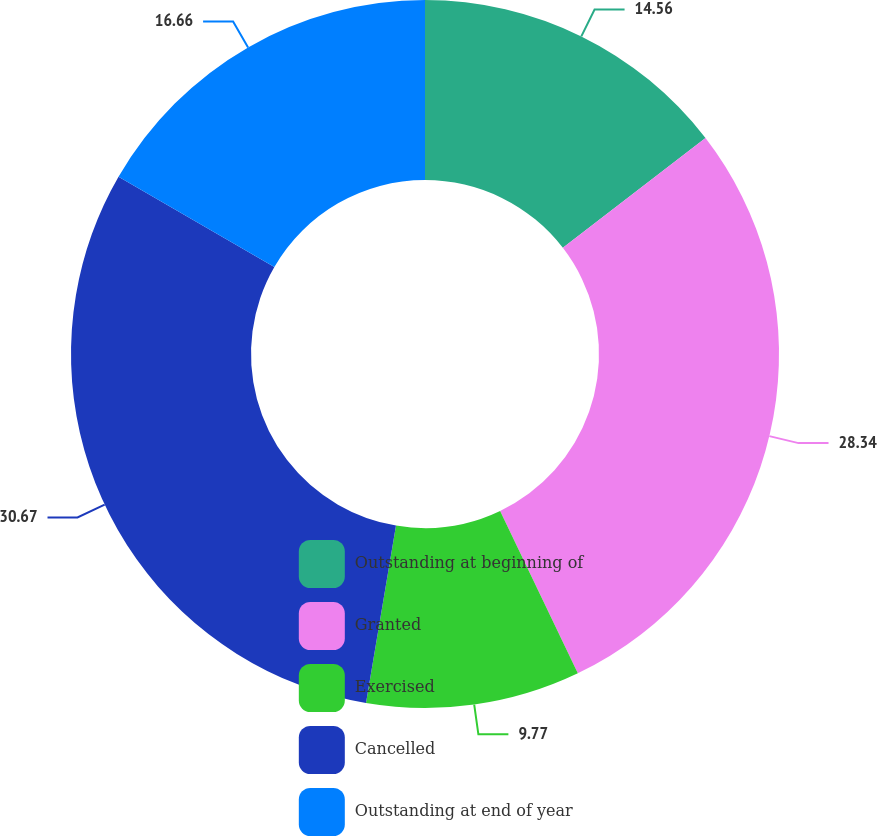Convert chart to OTSL. <chart><loc_0><loc_0><loc_500><loc_500><pie_chart><fcel>Outstanding at beginning of<fcel>Granted<fcel>Exercised<fcel>Cancelled<fcel>Outstanding at end of year<nl><fcel>14.56%<fcel>28.34%<fcel>9.77%<fcel>30.68%<fcel>16.66%<nl></chart> 